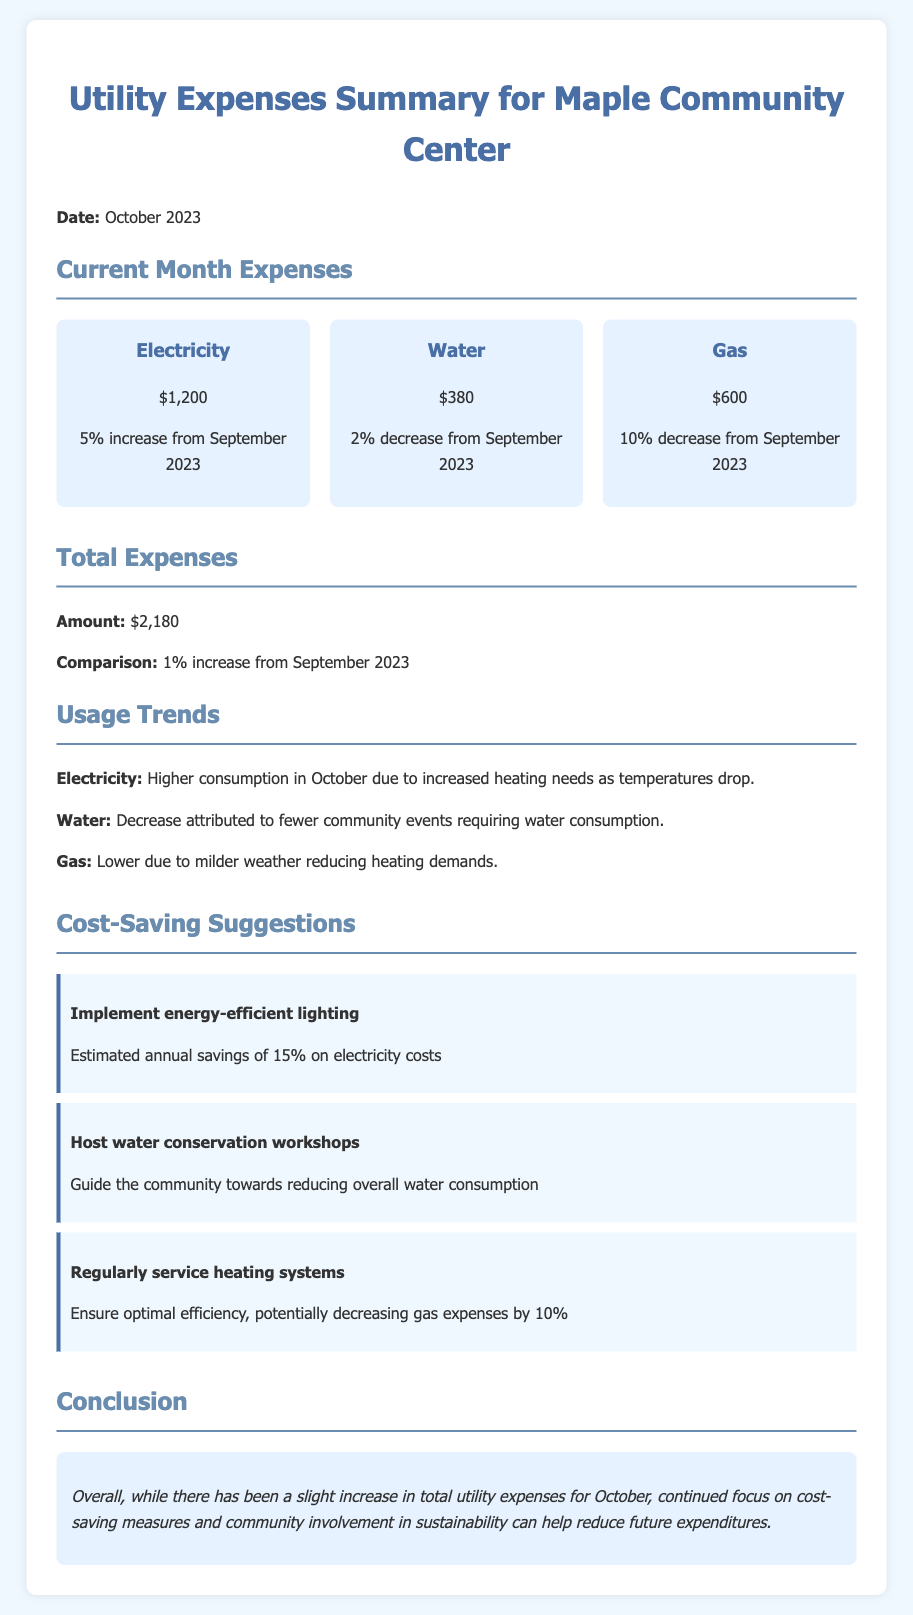What is the total amount of electricity expenses for October 2023? The electricity expense for October 2023 is detailed as $1,200 in the document.
Answer: $1,200 What was the percentage increase in electricity expenses from September 2023 to October 2023? The document states that there was a 5% increase in electricity expenses from the previous month.
Answer: 5% What is the total utility expense for the community center in October 2023? The total utility expenses for October 2023 are summed up to be $2,180.
Answer: $2,180 What suggestion is made to reduce electricity costs? The document suggests implementing energy-efficient lighting to achieve savings.
Answer: Energy-efficient lighting What was the percentage decrease in gas expenses from September 2023? The gas expenses in October 2023 show a 10% decrease as per the report.
Answer: 10% Why did the water expenses decrease in October 2023? The decrease in water expenses is attributed to fewer community events that used water.
Answer: Fewer community events What is the potential annual savings from energy-efficient lighting? The potential savings from implementing energy-efficient lighting is stated to be 15% on electricity costs.
Answer: 15% What is the main conclusion regarding the total utility expenses for October? The conclusion states that there has been a slight increase in total utility expenses for October.
Answer: Slight increase What is one suggested measure to save on gas expenses? The document suggests regularly servicing heating systems to ensure efficiency and potentially decrease costs.
Answer: Regularly service heating systems 